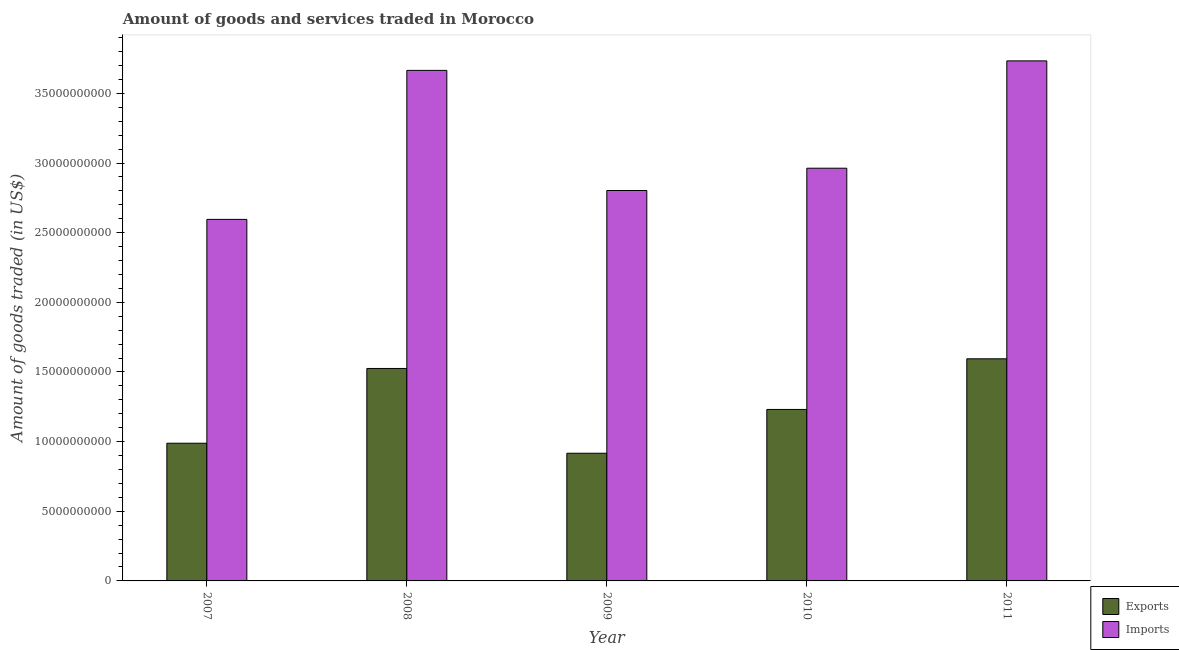How many different coloured bars are there?
Your answer should be very brief. 2. How many groups of bars are there?
Ensure brevity in your answer.  5. How many bars are there on the 2nd tick from the left?
Offer a terse response. 2. What is the label of the 3rd group of bars from the left?
Provide a succinct answer. 2009. In how many cases, is the number of bars for a given year not equal to the number of legend labels?
Ensure brevity in your answer.  0. What is the amount of goods imported in 2010?
Your answer should be compact. 2.96e+1. Across all years, what is the maximum amount of goods exported?
Your answer should be very brief. 1.59e+1. Across all years, what is the minimum amount of goods imported?
Provide a succinct answer. 2.60e+1. In which year was the amount of goods imported maximum?
Provide a succinct answer. 2011. What is the total amount of goods exported in the graph?
Offer a very short reply. 6.26e+1. What is the difference between the amount of goods imported in 2008 and that in 2010?
Offer a terse response. 7.02e+09. What is the difference between the amount of goods exported in 2011 and the amount of goods imported in 2008?
Provide a succinct answer. 6.94e+08. What is the average amount of goods imported per year?
Keep it short and to the point. 3.15e+1. In the year 2011, what is the difference between the amount of goods exported and amount of goods imported?
Keep it short and to the point. 0. In how many years, is the amount of goods imported greater than 31000000000 US$?
Offer a terse response. 2. What is the ratio of the amount of goods exported in 2008 to that in 2009?
Keep it short and to the point. 1.66. Is the amount of goods imported in 2009 less than that in 2010?
Give a very brief answer. Yes. Is the difference between the amount of goods imported in 2008 and 2011 greater than the difference between the amount of goods exported in 2008 and 2011?
Your answer should be very brief. No. What is the difference between the highest and the second highest amount of goods imported?
Give a very brief answer. 6.82e+08. What is the difference between the highest and the lowest amount of goods exported?
Offer a terse response. 6.78e+09. In how many years, is the amount of goods exported greater than the average amount of goods exported taken over all years?
Provide a succinct answer. 2. Is the sum of the amount of goods exported in 2007 and 2011 greater than the maximum amount of goods imported across all years?
Make the answer very short. Yes. What does the 1st bar from the left in 2009 represents?
Offer a terse response. Exports. What does the 2nd bar from the right in 2010 represents?
Make the answer very short. Exports. How many bars are there?
Your answer should be compact. 10. Are all the bars in the graph horizontal?
Your response must be concise. No. How many years are there in the graph?
Ensure brevity in your answer.  5. What is the difference between two consecutive major ticks on the Y-axis?
Your response must be concise. 5.00e+09. Does the graph contain any zero values?
Keep it short and to the point. No. Does the graph contain grids?
Ensure brevity in your answer.  No. What is the title of the graph?
Provide a short and direct response. Amount of goods and services traded in Morocco. What is the label or title of the X-axis?
Give a very brief answer. Year. What is the label or title of the Y-axis?
Make the answer very short. Amount of goods traded (in US$). What is the Amount of goods traded (in US$) in Exports in 2007?
Make the answer very short. 9.88e+09. What is the Amount of goods traded (in US$) in Imports in 2007?
Offer a very short reply. 2.60e+1. What is the Amount of goods traded (in US$) of Exports in 2008?
Your response must be concise. 1.53e+1. What is the Amount of goods traded (in US$) of Imports in 2008?
Your answer should be compact. 3.67e+1. What is the Amount of goods traded (in US$) in Exports in 2009?
Your answer should be very brief. 9.17e+09. What is the Amount of goods traded (in US$) in Imports in 2009?
Your answer should be very brief. 2.80e+1. What is the Amount of goods traded (in US$) in Exports in 2010?
Your answer should be compact. 1.23e+1. What is the Amount of goods traded (in US$) of Imports in 2010?
Make the answer very short. 2.96e+1. What is the Amount of goods traded (in US$) in Exports in 2011?
Keep it short and to the point. 1.59e+1. What is the Amount of goods traded (in US$) in Imports in 2011?
Provide a short and direct response. 3.73e+1. Across all years, what is the maximum Amount of goods traded (in US$) of Exports?
Keep it short and to the point. 1.59e+1. Across all years, what is the maximum Amount of goods traded (in US$) of Imports?
Provide a short and direct response. 3.73e+1. Across all years, what is the minimum Amount of goods traded (in US$) in Exports?
Make the answer very short. 9.17e+09. Across all years, what is the minimum Amount of goods traded (in US$) of Imports?
Offer a very short reply. 2.60e+1. What is the total Amount of goods traded (in US$) of Exports in the graph?
Provide a short and direct response. 6.26e+1. What is the total Amount of goods traded (in US$) in Imports in the graph?
Your response must be concise. 1.58e+11. What is the difference between the Amount of goods traded (in US$) in Exports in 2007 and that in 2008?
Provide a short and direct response. -5.37e+09. What is the difference between the Amount of goods traded (in US$) of Imports in 2007 and that in 2008?
Ensure brevity in your answer.  -1.07e+1. What is the difference between the Amount of goods traded (in US$) in Exports in 2007 and that in 2009?
Your answer should be compact. 7.19e+08. What is the difference between the Amount of goods traded (in US$) of Imports in 2007 and that in 2009?
Your answer should be compact. -2.07e+09. What is the difference between the Amount of goods traded (in US$) in Exports in 2007 and that in 2010?
Your response must be concise. -2.42e+09. What is the difference between the Amount of goods traded (in US$) in Imports in 2007 and that in 2010?
Ensure brevity in your answer.  -3.67e+09. What is the difference between the Amount of goods traded (in US$) of Exports in 2007 and that in 2011?
Give a very brief answer. -6.06e+09. What is the difference between the Amount of goods traded (in US$) of Imports in 2007 and that in 2011?
Your answer should be very brief. -1.14e+1. What is the difference between the Amount of goods traded (in US$) in Exports in 2008 and that in 2009?
Provide a short and direct response. 6.09e+09. What is the difference between the Amount of goods traded (in US$) in Imports in 2008 and that in 2009?
Offer a terse response. 8.62e+09. What is the difference between the Amount of goods traded (in US$) in Exports in 2008 and that in 2010?
Ensure brevity in your answer.  2.94e+09. What is the difference between the Amount of goods traded (in US$) in Imports in 2008 and that in 2010?
Offer a terse response. 7.02e+09. What is the difference between the Amount of goods traded (in US$) in Exports in 2008 and that in 2011?
Your answer should be compact. -6.94e+08. What is the difference between the Amount of goods traded (in US$) in Imports in 2008 and that in 2011?
Offer a terse response. -6.82e+08. What is the difference between the Amount of goods traded (in US$) of Exports in 2009 and that in 2010?
Your response must be concise. -3.14e+09. What is the difference between the Amount of goods traded (in US$) in Imports in 2009 and that in 2010?
Offer a very short reply. -1.60e+09. What is the difference between the Amount of goods traded (in US$) in Exports in 2009 and that in 2011?
Provide a succinct answer. -6.78e+09. What is the difference between the Amount of goods traded (in US$) in Imports in 2009 and that in 2011?
Offer a terse response. -9.31e+09. What is the difference between the Amount of goods traded (in US$) in Exports in 2010 and that in 2011?
Offer a very short reply. -3.64e+09. What is the difference between the Amount of goods traded (in US$) in Imports in 2010 and that in 2011?
Your response must be concise. -7.71e+09. What is the difference between the Amount of goods traded (in US$) in Exports in 2007 and the Amount of goods traded (in US$) in Imports in 2008?
Offer a terse response. -2.68e+1. What is the difference between the Amount of goods traded (in US$) of Exports in 2007 and the Amount of goods traded (in US$) of Imports in 2009?
Give a very brief answer. -1.81e+1. What is the difference between the Amount of goods traded (in US$) in Exports in 2007 and the Amount of goods traded (in US$) in Imports in 2010?
Your answer should be very brief. -1.97e+1. What is the difference between the Amount of goods traded (in US$) of Exports in 2007 and the Amount of goods traded (in US$) of Imports in 2011?
Provide a succinct answer. -2.74e+1. What is the difference between the Amount of goods traded (in US$) of Exports in 2008 and the Amount of goods traded (in US$) of Imports in 2009?
Make the answer very short. -1.28e+1. What is the difference between the Amount of goods traded (in US$) of Exports in 2008 and the Amount of goods traded (in US$) of Imports in 2010?
Make the answer very short. -1.44e+1. What is the difference between the Amount of goods traded (in US$) of Exports in 2008 and the Amount of goods traded (in US$) of Imports in 2011?
Keep it short and to the point. -2.21e+1. What is the difference between the Amount of goods traded (in US$) in Exports in 2009 and the Amount of goods traded (in US$) in Imports in 2010?
Offer a very short reply. -2.05e+1. What is the difference between the Amount of goods traded (in US$) of Exports in 2009 and the Amount of goods traded (in US$) of Imports in 2011?
Provide a short and direct response. -2.82e+1. What is the difference between the Amount of goods traded (in US$) in Exports in 2010 and the Amount of goods traded (in US$) in Imports in 2011?
Provide a succinct answer. -2.50e+1. What is the average Amount of goods traded (in US$) in Exports per year?
Your answer should be very brief. 1.25e+1. What is the average Amount of goods traded (in US$) in Imports per year?
Provide a succinct answer. 3.15e+1. In the year 2007, what is the difference between the Amount of goods traded (in US$) in Exports and Amount of goods traded (in US$) in Imports?
Make the answer very short. -1.61e+1. In the year 2008, what is the difference between the Amount of goods traded (in US$) of Exports and Amount of goods traded (in US$) of Imports?
Give a very brief answer. -2.14e+1. In the year 2009, what is the difference between the Amount of goods traded (in US$) in Exports and Amount of goods traded (in US$) in Imports?
Provide a short and direct response. -1.89e+1. In the year 2010, what is the difference between the Amount of goods traded (in US$) in Exports and Amount of goods traded (in US$) in Imports?
Provide a short and direct response. -1.73e+1. In the year 2011, what is the difference between the Amount of goods traded (in US$) of Exports and Amount of goods traded (in US$) of Imports?
Offer a very short reply. -2.14e+1. What is the ratio of the Amount of goods traded (in US$) of Exports in 2007 to that in 2008?
Ensure brevity in your answer.  0.65. What is the ratio of the Amount of goods traded (in US$) of Imports in 2007 to that in 2008?
Ensure brevity in your answer.  0.71. What is the ratio of the Amount of goods traded (in US$) of Exports in 2007 to that in 2009?
Your answer should be compact. 1.08. What is the ratio of the Amount of goods traded (in US$) of Imports in 2007 to that in 2009?
Your response must be concise. 0.93. What is the ratio of the Amount of goods traded (in US$) in Exports in 2007 to that in 2010?
Keep it short and to the point. 0.8. What is the ratio of the Amount of goods traded (in US$) in Imports in 2007 to that in 2010?
Give a very brief answer. 0.88. What is the ratio of the Amount of goods traded (in US$) in Exports in 2007 to that in 2011?
Give a very brief answer. 0.62. What is the ratio of the Amount of goods traded (in US$) in Imports in 2007 to that in 2011?
Ensure brevity in your answer.  0.7. What is the ratio of the Amount of goods traded (in US$) in Exports in 2008 to that in 2009?
Your answer should be very brief. 1.66. What is the ratio of the Amount of goods traded (in US$) in Imports in 2008 to that in 2009?
Offer a terse response. 1.31. What is the ratio of the Amount of goods traded (in US$) of Exports in 2008 to that in 2010?
Provide a succinct answer. 1.24. What is the ratio of the Amount of goods traded (in US$) in Imports in 2008 to that in 2010?
Your answer should be compact. 1.24. What is the ratio of the Amount of goods traded (in US$) in Exports in 2008 to that in 2011?
Your response must be concise. 0.96. What is the ratio of the Amount of goods traded (in US$) in Imports in 2008 to that in 2011?
Your answer should be very brief. 0.98. What is the ratio of the Amount of goods traded (in US$) in Exports in 2009 to that in 2010?
Provide a short and direct response. 0.74. What is the ratio of the Amount of goods traded (in US$) in Imports in 2009 to that in 2010?
Keep it short and to the point. 0.95. What is the ratio of the Amount of goods traded (in US$) of Exports in 2009 to that in 2011?
Offer a very short reply. 0.57. What is the ratio of the Amount of goods traded (in US$) in Imports in 2009 to that in 2011?
Offer a terse response. 0.75. What is the ratio of the Amount of goods traded (in US$) in Exports in 2010 to that in 2011?
Give a very brief answer. 0.77. What is the ratio of the Amount of goods traded (in US$) of Imports in 2010 to that in 2011?
Your answer should be very brief. 0.79. What is the difference between the highest and the second highest Amount of goods traded (in US$) of Exports?
Your response must be concise. 6.94e+08. What is the difference between the highest and the second highest Amount of goods traded (in US$) in Imports?
Offer a terse response. 6.82e+08. What is the difference between the highest and the lowest Amount of goods traded (in US$) in Exports?
Keep it short and to the point. 6.78e+09. What is the difference between the highest and the lowest Amount of goods traded (in US$) in Imports?
Make the answer very short. 1.14e+1. 